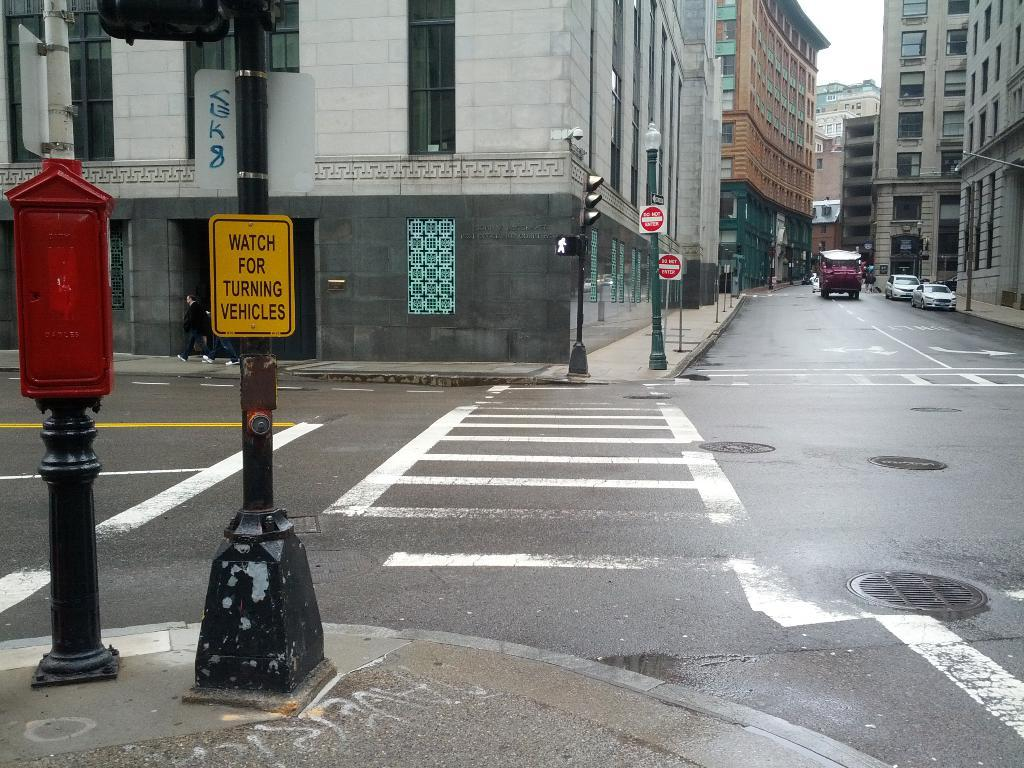<image>
Relay a brief, clear account of the picture shown. A sign instructs pedestrians to watch for turning vehicles. 